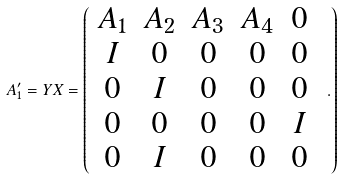Convert formula to latex. <formula><loc_0><loc_0><loc_500><loc_500>A ^ { \prime } _ { 1 } = Y X = \left ( \begin{array} { c c c c c } A _ { 1 } & A _ { 2 } & A _ { 3 } & A _ { 4 } & 0 \\ I & 0 & 0 & 0 & 0 \\ 0 & I & 0 & 0 & 0 \\ 0 & 0 & 0 & 0 & I \\ 0 & I & 0 & 0 & 0 \end{array} \ . \right )</formula> 